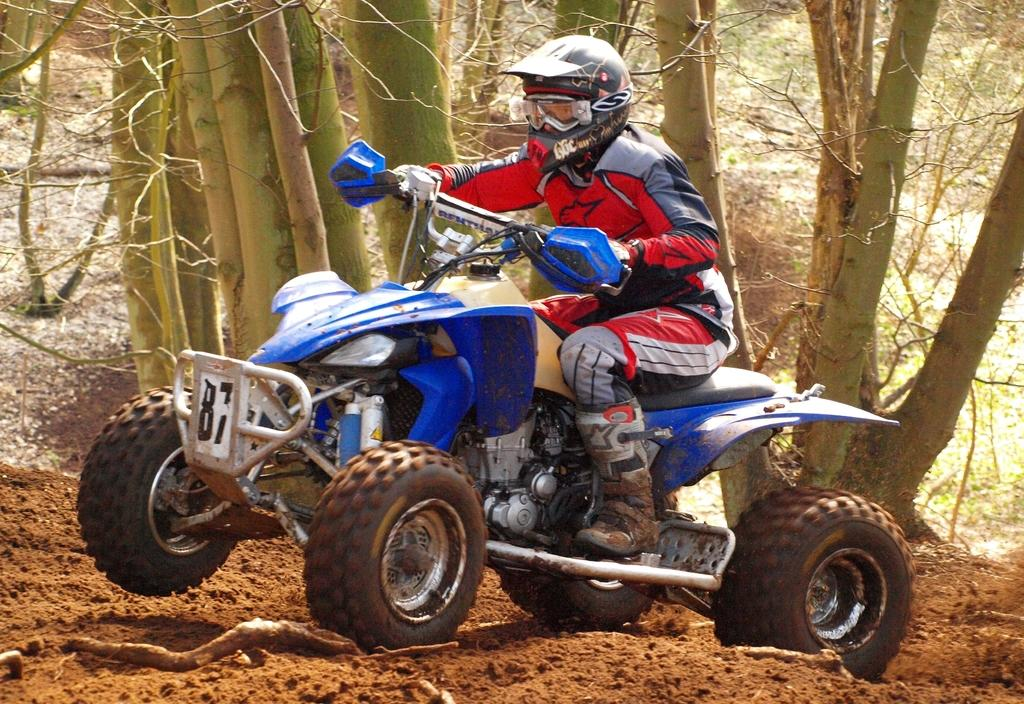What is the person in the image doing? There is a person sitting on a vehicle in the image. What can be seen in the background of the image? There are trees in the background of the image. What type of vegetation is present in the image? There are dead plants in the image. What type of pan is being used to cook food in the image? There is no pan or cooking activity present in the image. What does the van in the image smell like? There is no van present in the image, so it is not possible to determine what it might smell like. 